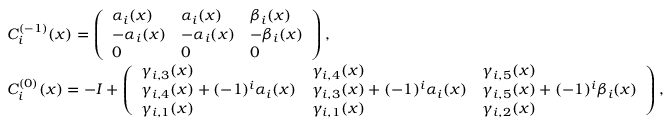<formula> <loc_0><loc_0><loc_500><loc_500>\begin{array} { r l } & { C _ { i } ^ { ( - 1 ) } ( x ) = \left ( \begin{array} { l l l } { \alpha _ { i } ( x ) } & { \alpha _ { i } ( x ) } & { \beta _ { i } ( x ) } \\ { - \alpha _ { i } ( x ) } & { - \alpha _ { i } ( x ) } & { - \beta _ { i } ( x ) } \\ { 0 } & { 0 } & { 0 } \end{array} \right ) , } \\ & { C _ { i } ^ { ( 0 ) } ( x ) = - I + \left ( \begin{array} { l l l } { \gamma _ { i , 3 } ( x ) } & { \gamma _ { i , 4 } ( x ) } & { \gamma _ { i , 5 } ( x ) } \\ { \gamma _ { i , 4 } ( x ) + ( - 1 ) ^ { i } \alpha _ { i } ( x ) } & { \gamma _ { i , 3 } ( x ) + ( - 1 ) ^ { i } \alpha _ { i } ( x ) } & { \gamma _ { i , 5 } ( x ) + ( - 1 ) ^ { i } \beta _ { i } ( x ) } \\ { \gamma _ { i , 1 } ( x ) } & { \gamma _ { i , 1 } ( x ) } & { \gamma _ { i , 2 } ( x ) } \end{array} \right ) , } \end{array}</formula> 